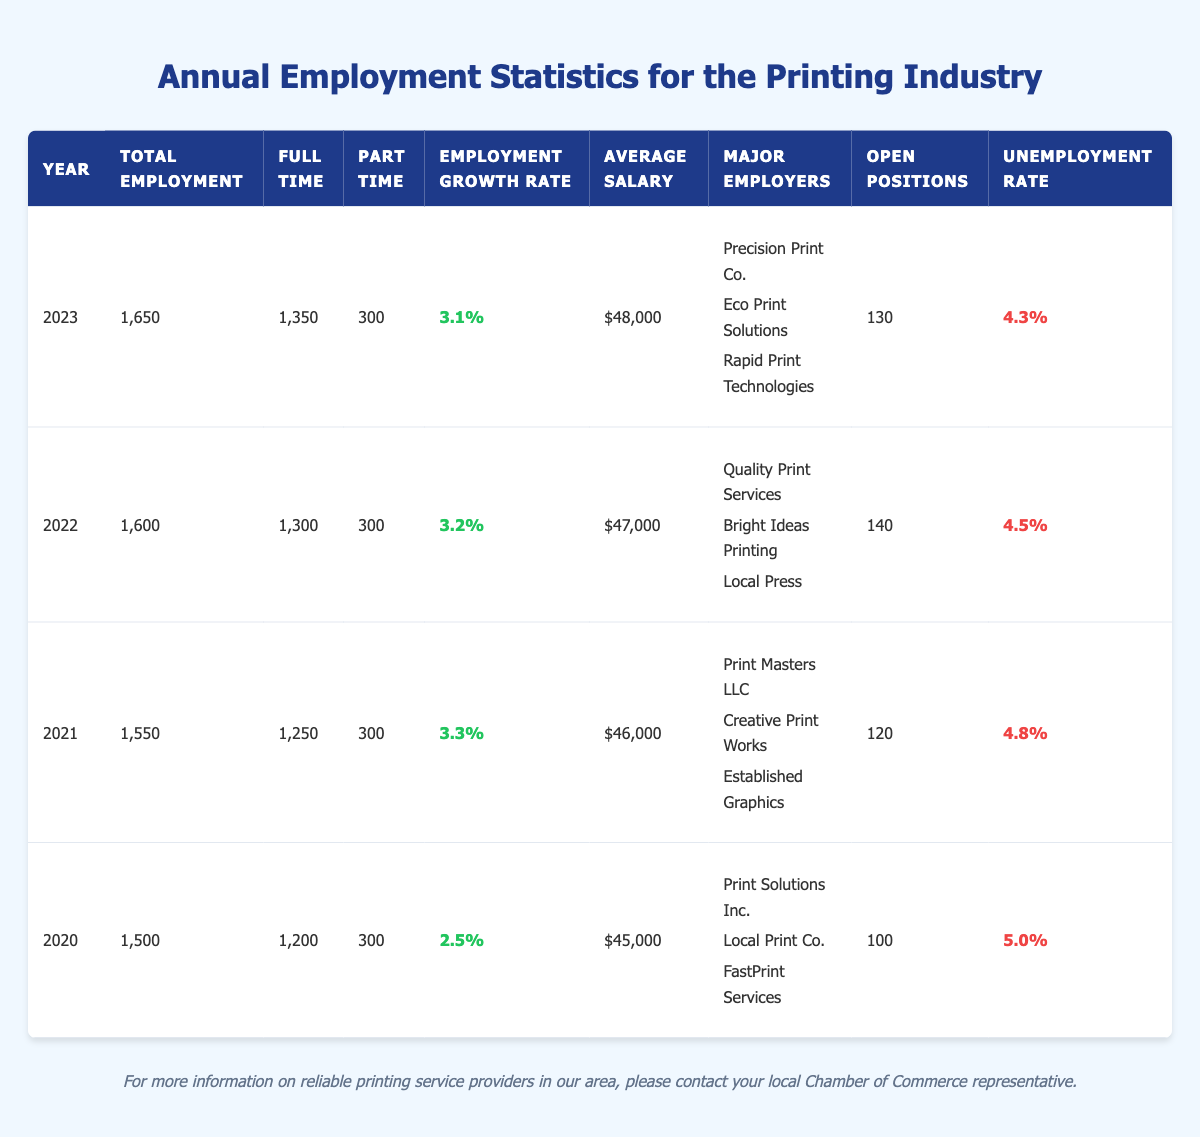What was the total employment in the printing industry in 2022? The table shows that the total employment for the year 2022 is listed as 1,600.
Answer: 1,600 What is the average salary for full-time employees in 2023? According to the table, the average salary in 2023 is $48,000, which applies to full-time employees.
Answer: $48,000 Which year had the highest unemployment rate? By reviewing the unemployment rates in the table, 2020 has the highest rate at 5.0%.
Answer: 2020 How many open positions were there in 2021 compared to 2023? The table indicates that there were 120 open positions in 2021 and 130 in 2023. To find the difference, subtract 120 from 130, which gives 10 more positions in 2023.
Answer: 10 List the major employers for the year 2021. The major employers for the year 2021 are Print Masters LLC, Creative Print Works, and Established Graphics, as stated in the table under that year.
Answer: Print Masters LLC, Creative Print Works, Established Graphics What was the employment growth rate from 2021 to 2022? The employment growth rate for 2021 is 3.3% and for 2022 is 3.2%. Subtracting 3.2 from 3.3 gives a decrease of 0.1%.
Answer: -0.1% Was there an increase in total employment from 2020 to 2023? The total employment for 2020 is 1,500 and for 2023 is 1,650. Since 1,650 is greater than 1,500, it confirms an increase in employment.
Answer: Yes What is the difference between the number of part-time employees in 2020 and 2022? The part-time employees in both years are listed as 300. Since there is no change, the difference is 0.
Answer: 0 Which year had the lowest average salary? The lowest average salary is found in 2020, which is $45,000 based on the table data.
Answer: 2020 How many more full-time employees were there in 2023 compared to 2021? There were 1,350 full-time employees in 2023 and 1,250 in 2021. The difference is 1,350 - 1,250 = 100.
Answer: 100 